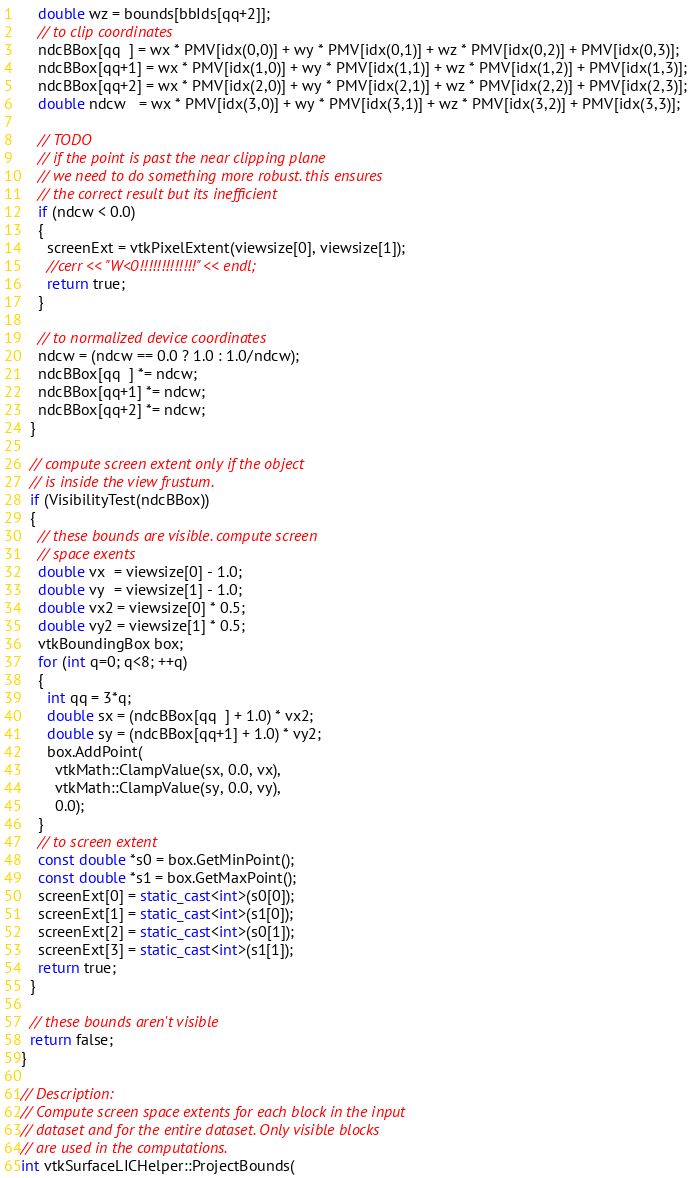<code> <loc_0><loc_0><loc_500><loc_500><_C++_>    double wz = bounds[bbIds[qq+2]];
    // to clip coordinates
    ndcBBox[qq  ] = wx * PMV[idx(0,0)] + wy * PMV[idx(0,1)] + wz * PMV[idx(0,2)] + PMV[idx(0,3)];
    ndcBBox[qq+1] = wx * PMV[idx(1,0)] + wy * PMV[idx(1,1)] + wz * PMV[idx(1,2)] + PMV[idx(1,3)];
    ndcBBox[qq+2] = wx * PMV[idx(2,0)] + wy * PMV[idx(2,1)] + wz * PMV[idx(2,2)] + PMV[idx(2,3)];
    double ndcw   = wx * PMV[idx(3,0)] + wy * PMV[idx(3,1)] + wz * PMV[idx(3,2)] + PMV[idx(3,3)];

    // TODO
    // if the point is past the near clipping plane
    // we need to do something more robust. this ensures
    // the correct result but its inefficient
    if (ndcw < 0.0)
    {
      screenExt = vtkPixelExtent(viewsize[0], viewsize[1]);
      //cerr << "W<0!!!!!!!!!!!!!" << endl;
      return true;
    }

    // to normalized device coordinates
    ndcw = (ndcw == 0.0 ? 1.0 : 1.0/ndcw);
    ndcBBox[qq  ] *= ndcw;
    ndcBBox[qq+1] *= ndcw;
    ndcBBox[qq+2] *= ndcw;
  }

  // compute screen extent only if the object
  // is inside the view frustum.
  if (VisibilityTest(ndcBBox))
  {
    // these bounds are visible. compute screen
    // space exents
    double vx  = viewsize[0] - 1.0;
    double vy  = viewsize[1] - 1.0;
    double vx2 = viewsize[0] * 0.5;
    double vy2 = viewsize[1] * 0.5;
    vtkBoundingBox box;
    for (int q=0; q<8; ++q)
    {
      int qq = 3*q;
      double sx = (ndcBBox[qq  ] + 1.0) * vx2;
      double sy = (ndcBBox[qq+1] + 1.0) * vy2;
      box.AddPoint(
        vtkMath::ClampValue(sx, 0.0, vx),
        vtkMath::ClampValue(sy, 0.0, vy),
        0.0);
    }
    // to screen extent
    const double *s0 = box.GetMinPoint();
    const double *s1 = box.GetMaxPoint();
    screenExt[0] = static_cast<int>(s0[0]);
    screenExt[1] = static_cast<int>(s1[0]);
    screenExt[2] = static_cast<int>(s0[1]);
    screenExt[3] = static_cast<int>(s1[1]);
    return true;
  }

  // these bounds aren't visible
  return false;
}

// Description:
// Compute screen space extents for each block in the input
// dataset and for the entire dataset. Only visible blocks
// are used in the computations.
int vtkSurfaceLICHelper::ProjectBounds(</code> 